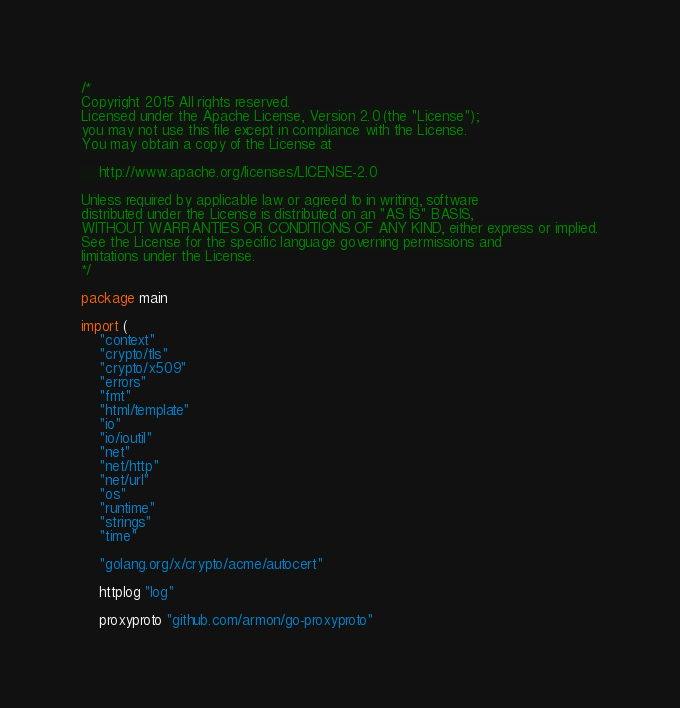<code> <loc_0><loc_0><loc_500><loc_500><_Go_>/*
Copyright 2015 All rights reserved.
Licensed under the Apache License, Version 2.0 (the "License");
you may not use this file except in compliance with the License.
You may obtain a copy of the License at

    http://www.apache.org/licenses/LICENSE-2.0

Unless required by applicable law or agreed to in writing, software
distributed under the License is distributed on an "AS IS" BASIS,
WITHOUT WARRANTIES OR CONDITIONS OF ANY KIND, either express or implied.
See the License for the specific language governing permissions and
limitations under the License.
*/

package main

import (
	"context"
	"crypto/tls"
	"crypto/x509"
	"errors"
	"fmt"
	"html/template"
	"io"
	"io/ioutil"
	"net"
	"net/http"
	"net/url"
	"os"
	"runtime"
	"strings"
	"time"

	"golang.org/x/crypto/acme/autocert"

	httplog "log"

	proxyproto "github.com/armon/go-proxyproto"</code> 